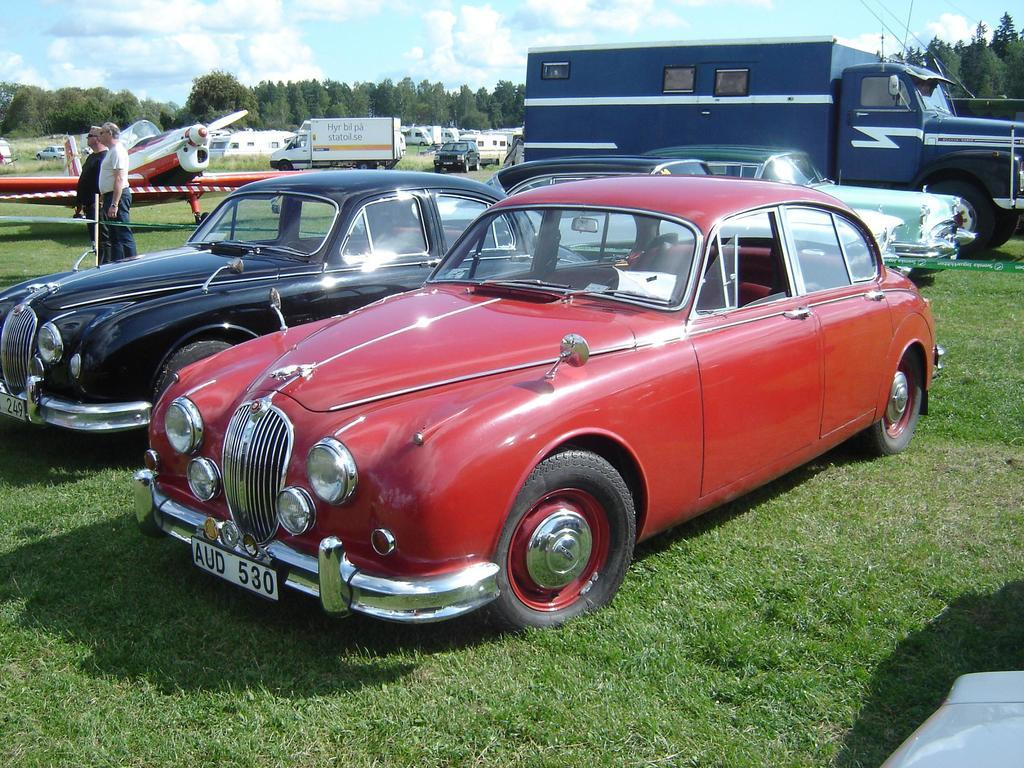What types of objects can be seen in the image? There are vehicles in the image. Can you describe the people in the image? There are two persons standing on the ground in the image. What type of natural environment is visible in the image? There are trees in the image. What is visible in the background of the image? The sky is visible in the background of the image, and clouds are present in the sky. What type of gold effect can be seen on the vehicles in the image? There is no gold effect present on the vehicles in the image. What process is being used to create the clouds in the image? The image is a photograph, and the clouds are naturally occurring in the sky, so there is no process being used to create them in the image. 